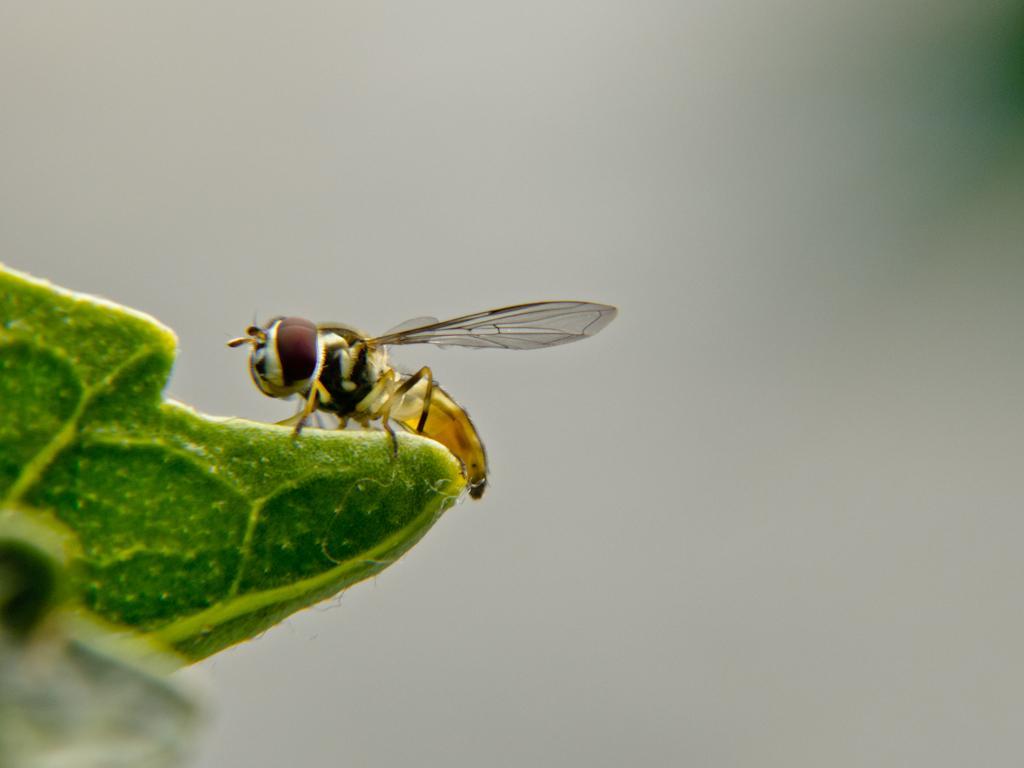How would you summarize this image in a sentence or two? Here we can see an insect on a green surface. There is a white background. 